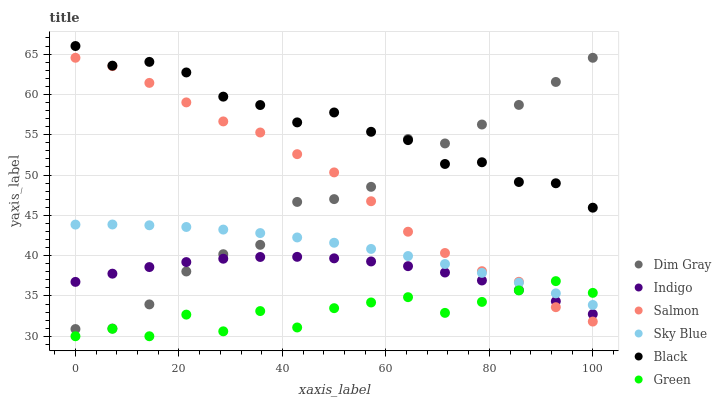Does Green have the minimum area under the curve?
Answer yes or no. Yes. Does Black have the maximum area under the curve?
Answer yes or no. Yes. Does Indigo have the minimum area under the curve?
Answer yes or no. No. Does Indigo have the maximum area under the curve?
Answer yes or no. No. Is Sky Blue the smoothest?
Answer yes or no. Yes. Is Green the roughest?
Answer yes or no. Yes. Is Indigo the smoothest?
Answer yes or no. No. Is Indigo the roughest?
Answer yes or no. No. Does Green have the lowest value?
Answer yes or no. Yes. Does Indigo have the lowest value?
Answer yes or no. No. Does Black have the highest value?
Answer yes or no. Yes. Does Indigo have the highest value?
Answer yes or no. No. Is Indigo less than Black?
Answer yes or no. Yes. Is Black greater than Sky Blue?
Answer yes or no. Yes. Does Black intersect Dim Gray?
Answer yes or no. Yes. Is Black less than Dim Gray?
Answer yes or no. No. Is Black greater than Dim Gray?
Answer yes or no. No. Does Indigo intersect Black?
Answer yes or no. No. 